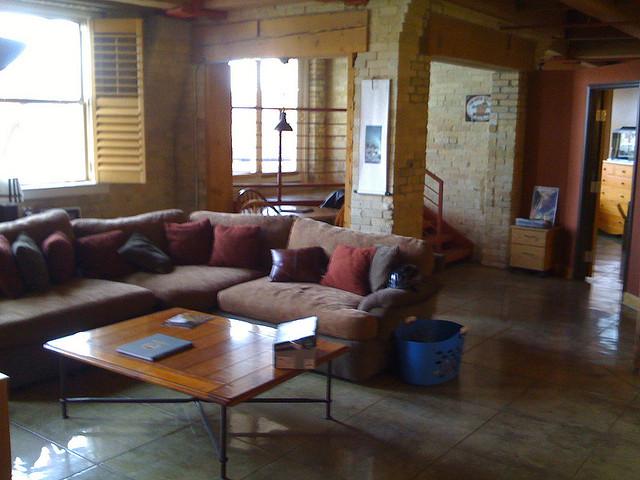What is the table made of?
Be succinct. Wood. How large is the sofa?
Be succinct. Large. What color is this table?
Short answer required. Brown. 